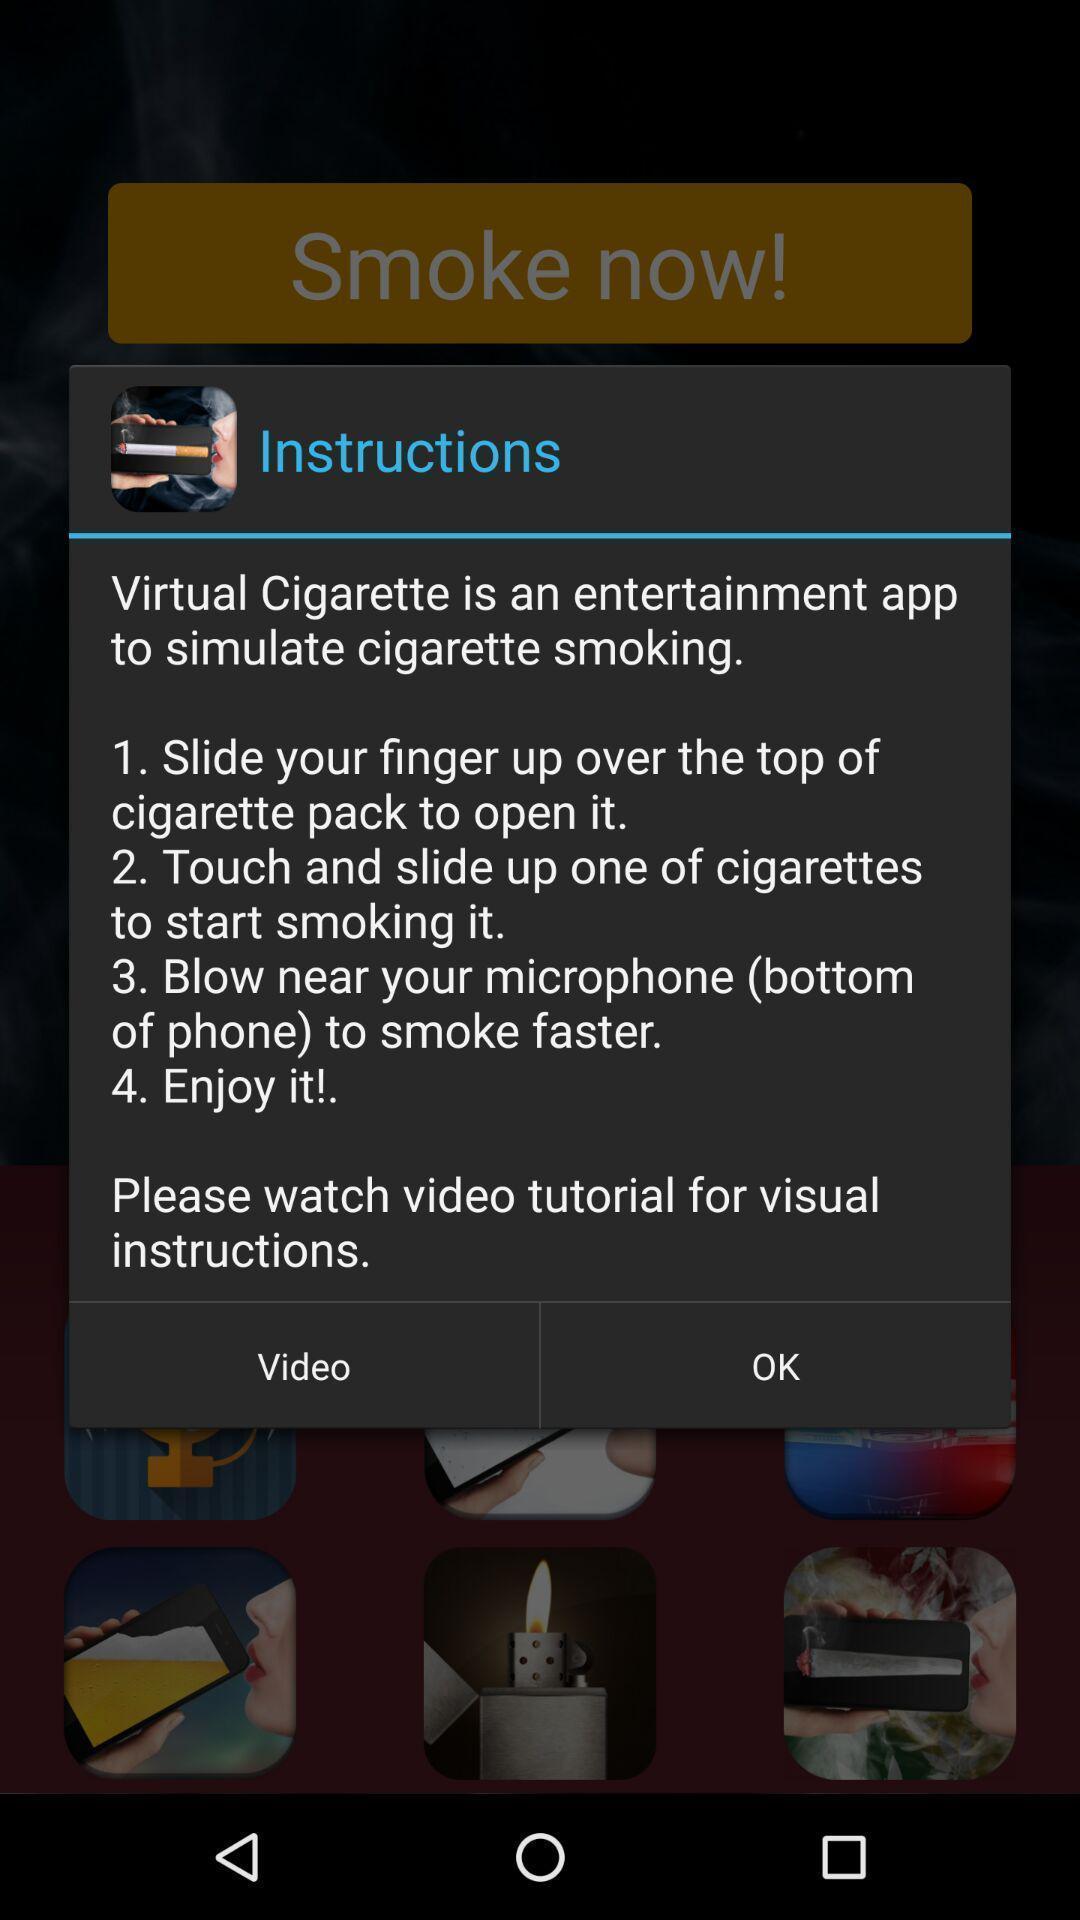Describe the visual elements of this screenshot. Popup displaying instructions of smoking app. 